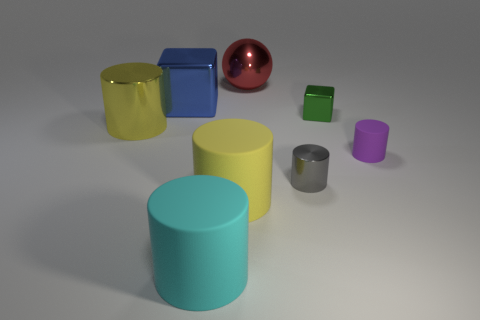How many yellow cylinders must be subtracted to get 1 yellow cylinders? 1 Subtract all gray metallic cylinders. How many cylinders are left? 4 Subtract all yellow spheres. How many yellow cylinders are left? 2 Add 1 small purple metal blocks. How many objects exist? 9 Subtract all yellow cylinders. How many cylinders are left? 3 Subtract all cylinders. How many objects are left? 3 Add 5 small gray cylinders. How many small gray cylinders are left? 6 Add 2 big yellow shiny balls. How many big yellow shiny balls exist? 2 Subtract 0 green balls. How many objects are left? 8 Subtract 3 cylinders. How many cylinders are left? 2 